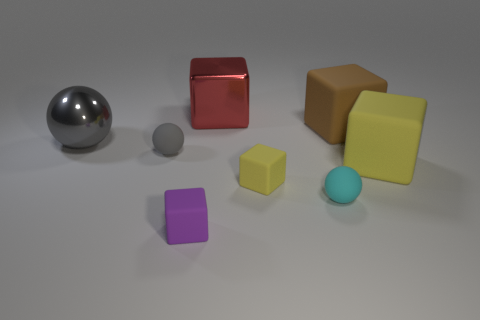Subtract all big matte blocks. How many blocks are left? 3 Subtract all yellow blocks. How many blocks are left? 3 Subtract all blocks. How many objects are left? 3 Subtract 4 blocks. How many blocks are left? 1 Add 2 small gray spheres. How many objects exist? 10 Subtract all gray spheres. How many brown blocks are left? 1 Subtract all purple matte objects. Subtract all matte objects. How many objects are left? 1 Add 2 large metal spheres. How many large metal spheres are left? 3 Add 1 small brown balls. How many small brown balls exist? 1 Subtract 0 purple spheres. How many objects are left? 8 